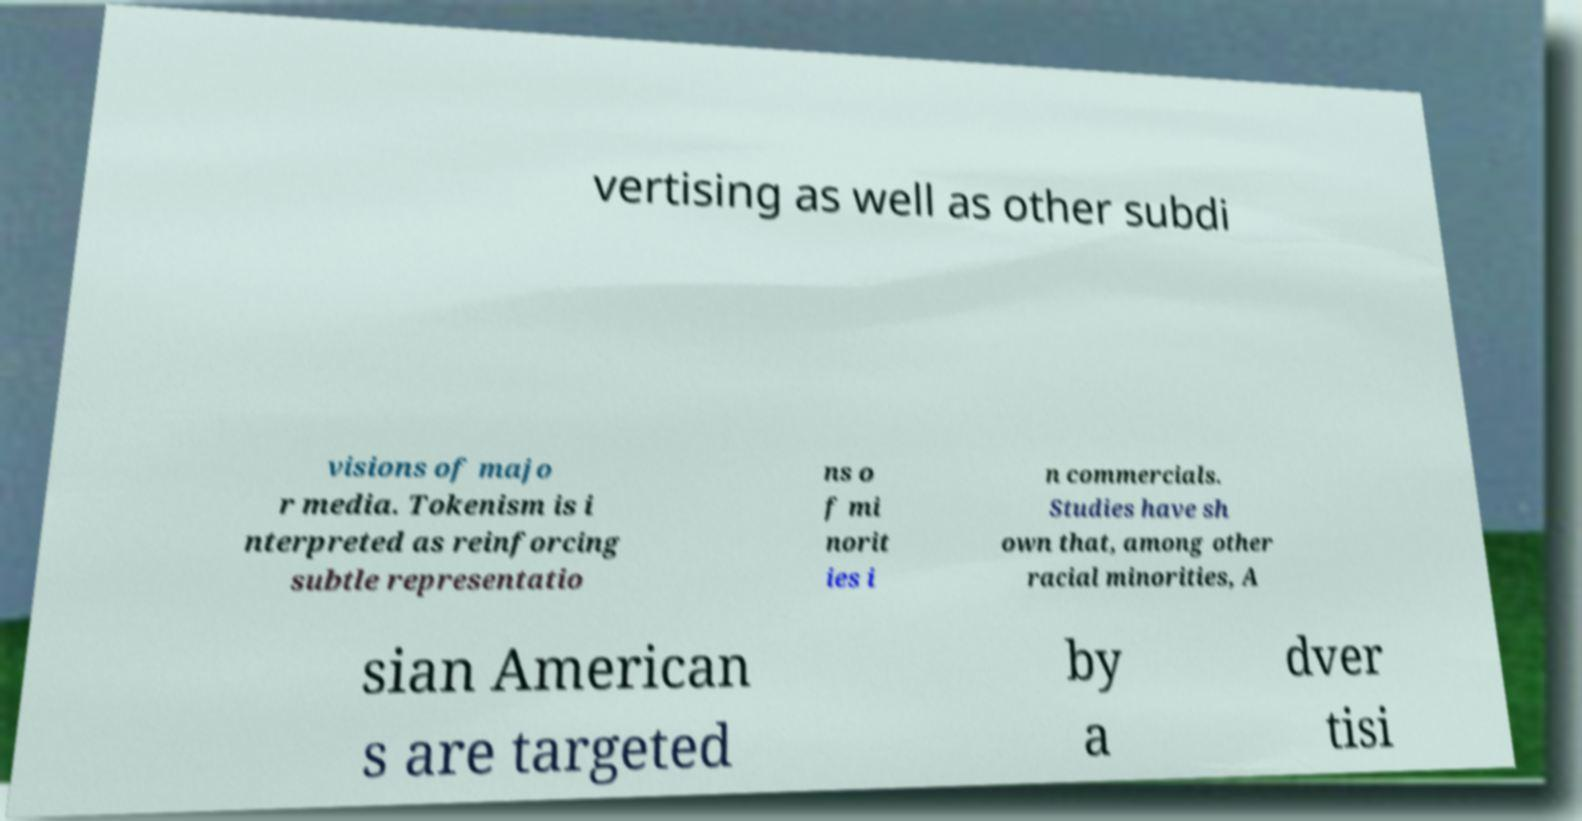There's text embedded in this image that I need extracted. Can you transcribe it verbatim? vertising as well as other subdi visions of majo r media. Tokenism is i nterpreted as reinforcing subtle representatio ns o f mi norit ies i n commercials. Studies have sh own that, among other racial minorities, A sian American s are targeted by a dver tisi 